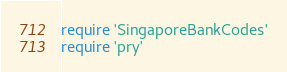Convert code to text. <code><loc_0><loc_0><loc_500><loc_500><_Ruby_>require 'SingaporeBankCodes'
require 'pry'
</code> 